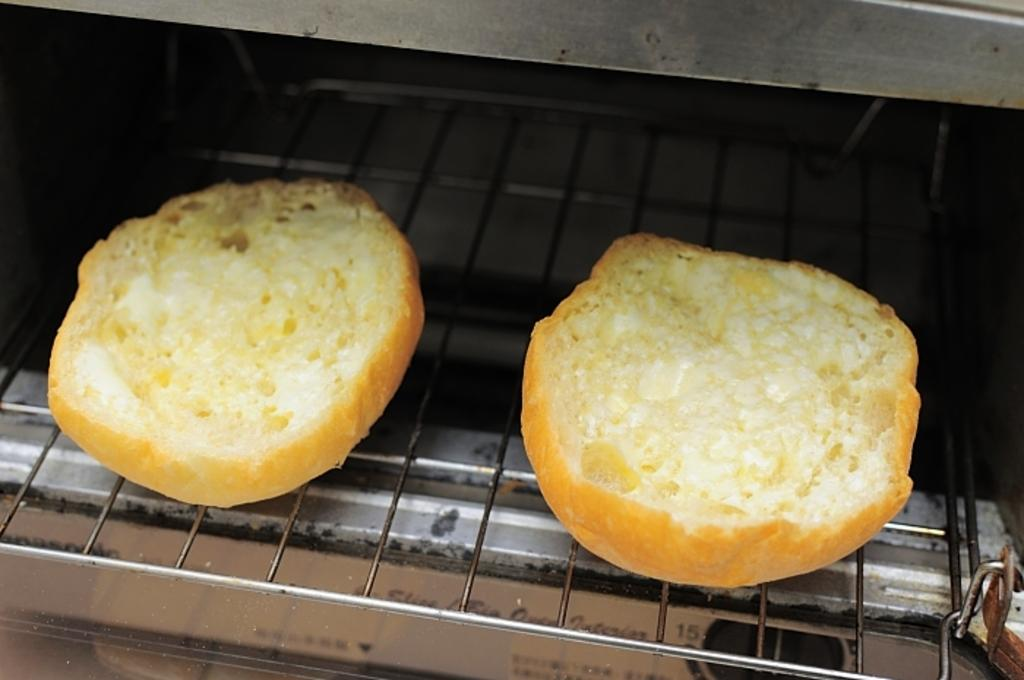What is the main object in the image? There is a grill in the image. What is placed on the grill? There are two buns on the grill. What type of shirt is being worn by the buns on the grill? There are no shirts present in the image, as the main subjects are a grill and two buns. 